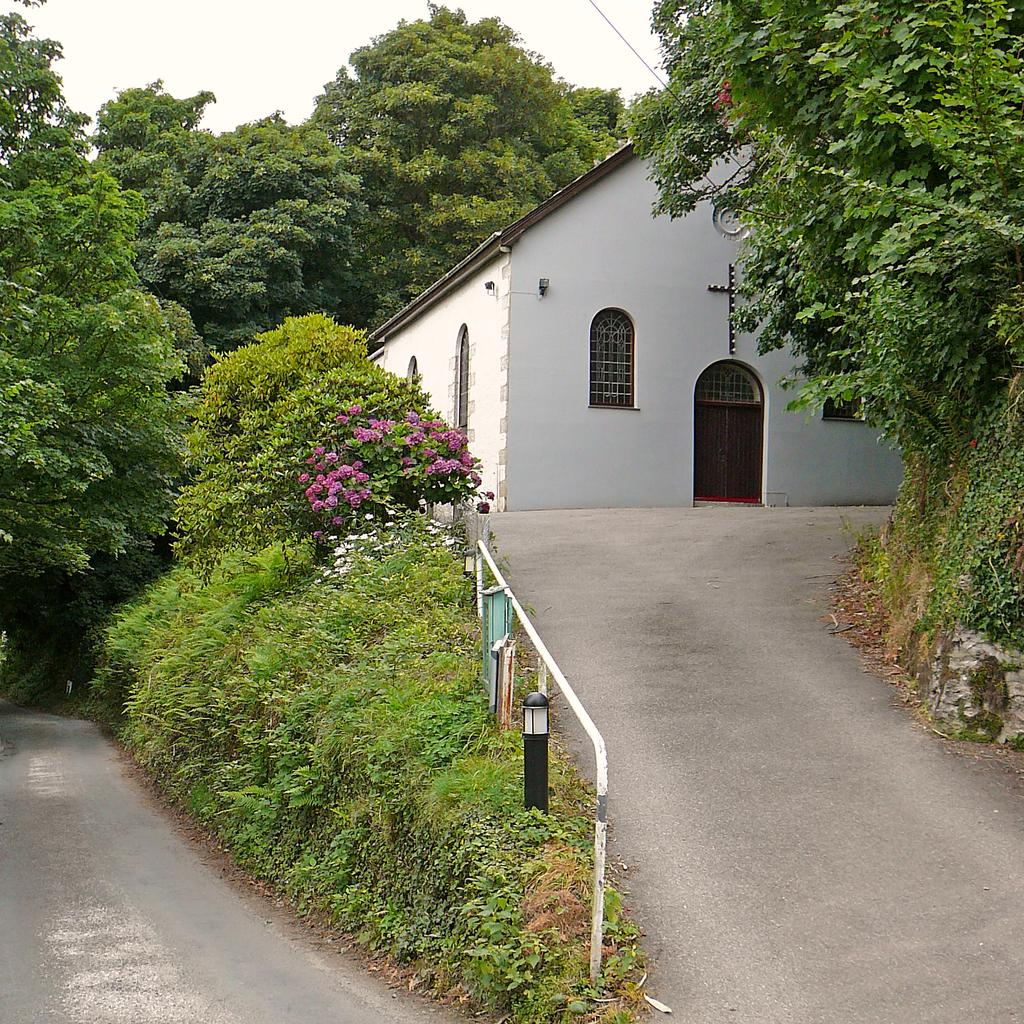What is the main feature in the foreground of the image? There is a road curve in the foreground of the image. What other elements can be seen in the foreground of the image? There are plants, a railing, and trees in the foreground of the image. What is visible in the background of the image? There is a shelter, trees, and the sky visible in the background of the image. What type of pleasure can be seen enjoying the sun in the image? There is no indication of pleasure or any living beings enjoying the sun in the image. 